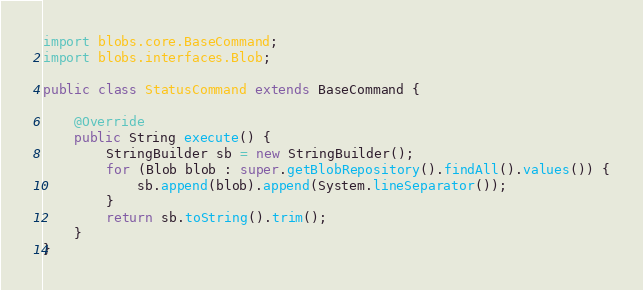<code> <loc_0><loc_0><loc_500><loc_500><_Java_>import blobs.core.BaseCommand;
import blobs.interfaces.Blob;

public class StatusCommand extends BaseCommand {

    @Override
    public String execute() {
        StringBuilder sb = new StringBuilder();
        for (Blob blob : super.getBlobRepository().findAll().values()) {
            sb.append(blob).append(System.lineSeparator());
        }
        return sb.toString().trim();
    }
}
</code> 